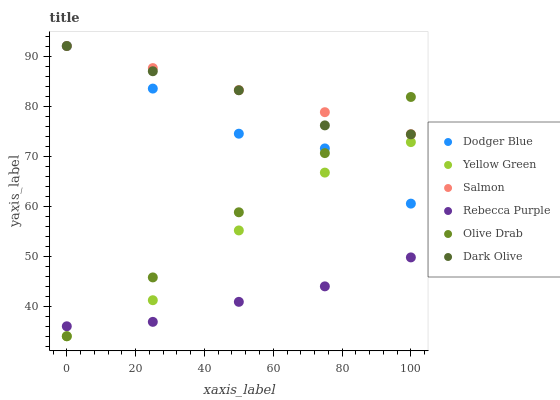Does Rebecca Purple have the minimum area under the curve?
Answer yes or no. Yes. Does Salmon have the maximum area under the curve?
Answer yes or no. Yes. Does Dark Olive have the minimum area under the curve?
Answer yes or no. No. Does Dark Olive have the maximum area under the curve?
Answer yes or no. No. Is Salmon the smoothest?
Answer yes or no. Yes. Is Dodger Blue the roughest?
Answer yes or no. Yes. Is Dark Olive the smoothest?
Answer yes or no. No. Is Dark Olive the roughest?
Answer yes or no. No. Does Yellow Green have the lowest value?
Answer yes or no. Yes. Does Dark Olive have the lowest value?
Answer yes or no. No. Does Dodger Blue have the highest value?
Answer yes or no. Yes. Does Rebecca Purple have the highest value?
Answer yes or no. No. Is Rebecca Purple less than Dark Olive?
Answer yes or no. Yes. Is Dark Olive greater than Rebecca Purple?
Answer yes or no. Yes. Does Yellow Green intersect Dodger Blue?
Answer yes or no. Yes. Is Yellow Green less than Dodger Blue?
Answer yes or no. No. Is Yellow Green greater than Dodger Blue?
Answer yes or no. No. Does Rebecca Purple intersect Dark Olive?
Answer yes or no. No. 